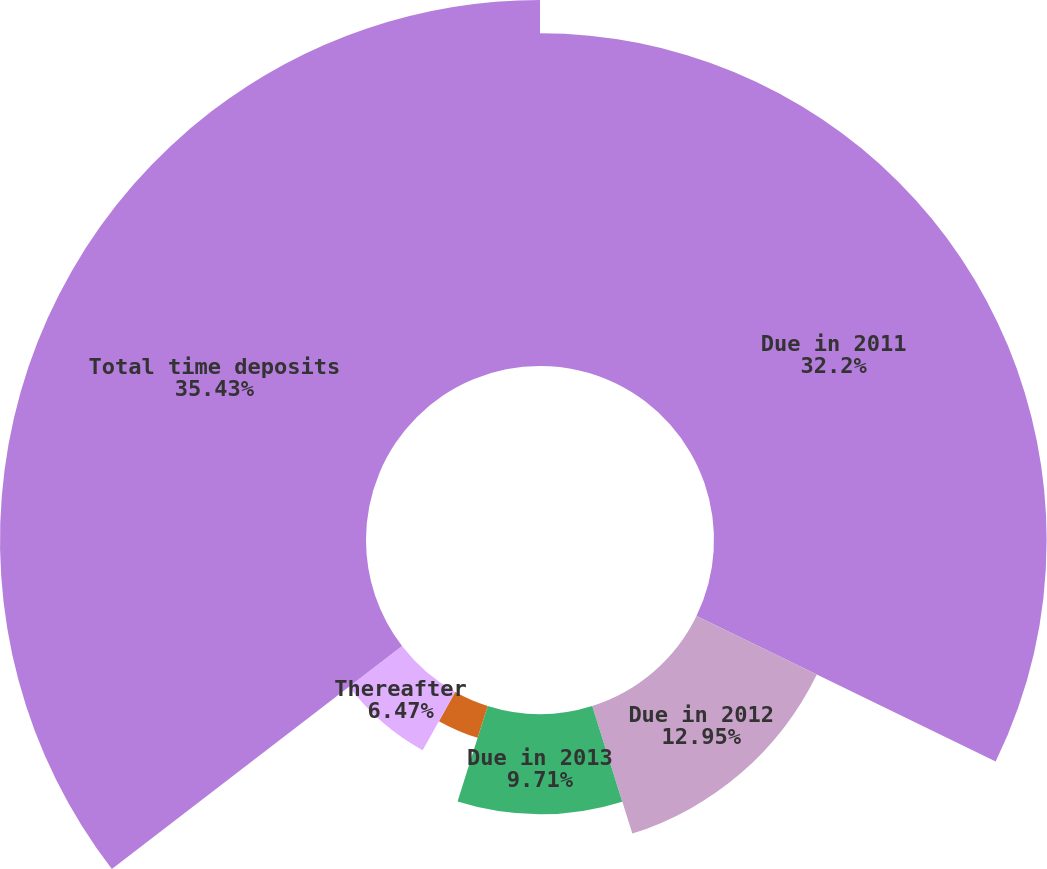<chart> <loc_0><loc_0><loc_500><loc_500><pie_chart><fcel>Due in 2011<fcel>Due in 2012<fcel>Due in 2013<fcel>Due in 2014<fcel>Due in 2015<fcel>Thereafter<fcel>Total time deposits<nl><fcel>32.2%<fcel>12.95%<fcel>9.71%<fcel>3.24%<fcel>0.0%<fcel>6.47%<fcel>35.43%<nl></chart> 